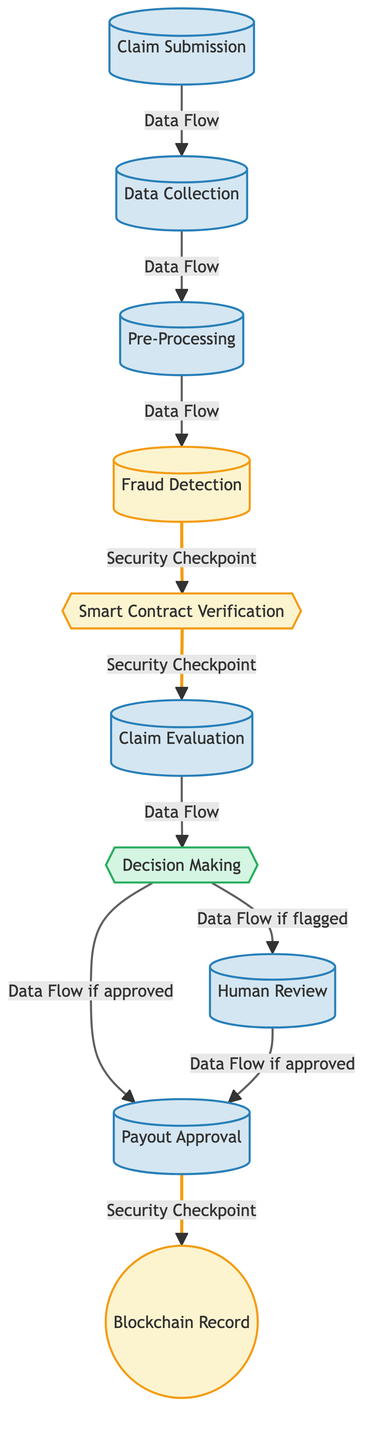What is the first step in the workflow? The first step in the automated claims processing workflow shown in the diagram is "Claim Submission." This is indicated as the starting point of the process, depicted at the top of the flowchart.
Answer: Claim Submission How many processes are depicted in the diagram? By counting the nodes categorized as processes in the diagram, we find there are six nodes labeled as processes: Claim Submission, Data Collection, Pre-Processing, Claim Evaluation, Human Review, and Payout Approval.
Answer: 6 What is the relationship between Fraud Detection and Smart Contract Verification? The diagram shows Fraud Detection leading to a security checkpoint for Smart Contract Verification. This indicates that after fraud detection, the next step involves verifying smart contracts as a security measure.
Answer: Security Checkpoint What happens if the claim is flagged during Decision Making? According to the diagram, if a claim is flagged during the Decision Making step, the workflow diverts to Human Review for further evaluation. This is marked as a separate flow based on the decision made.
Answer: Human Review What's recorded in the Blockchain after Payout Approval? After Payout Approval, the final action in the workflow is the recording of the transaction in the "Blockchain Record." The diagram illustrates this step and indicates it as a security checkpoint, emphasizing the importance of recording for security purposes.
Answer: Blockchain Record What are the security check points represented in this diagram? The security checkpoints in the diagram are positioned between Fraud Detection and Smart Contract Verification, as well as between Payout Approval and Blockchain Record. These checkpoints serve to ensure the integrity of the related processes.
Answer: 2 Security Checkpoints What is required if the claim passes the Decision Making stage? If a claim passes the Decision Making stage on the diagram, it proceeds directly to Payout Approval without requiring any further review or processing. This indicates that a decision marked as approved leads directly to the payout process.
Answer: Payout Approval What node follows Data Collection? The diagram clearly shows that the node following Data Collection is Pre-Processing. This indicates that after collecting the data, the next action is to preprocess that data for further processing steps.
Answer: Pre-Processing How does the flow of the diagram diverge after Decision Making? The flow diverges based on the outcome of Decision Making; if a claim is approved, it goes directly to Payout Approval, while if it is flagged, it leads to Human Review. This shows a branching decision-making process within the workflow.
Answer: Branching Decision 